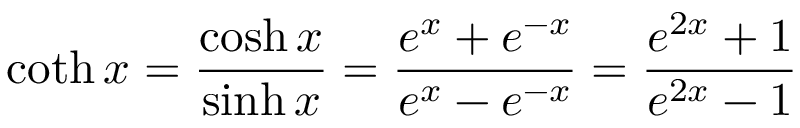Convert formula to latex. <formula><loc_0><loc_0><loc_500><loc_500>\coth x = { \frac { \cosh x } { \sinh x } } = { \frac { e ^ { x } + e ^ { - x } } { e ^ { x } - e ^ { - x } } } = { \frac { e ^ { 2 x } + 1 } { e ^ { 2 x } - 1 } }</formula> 